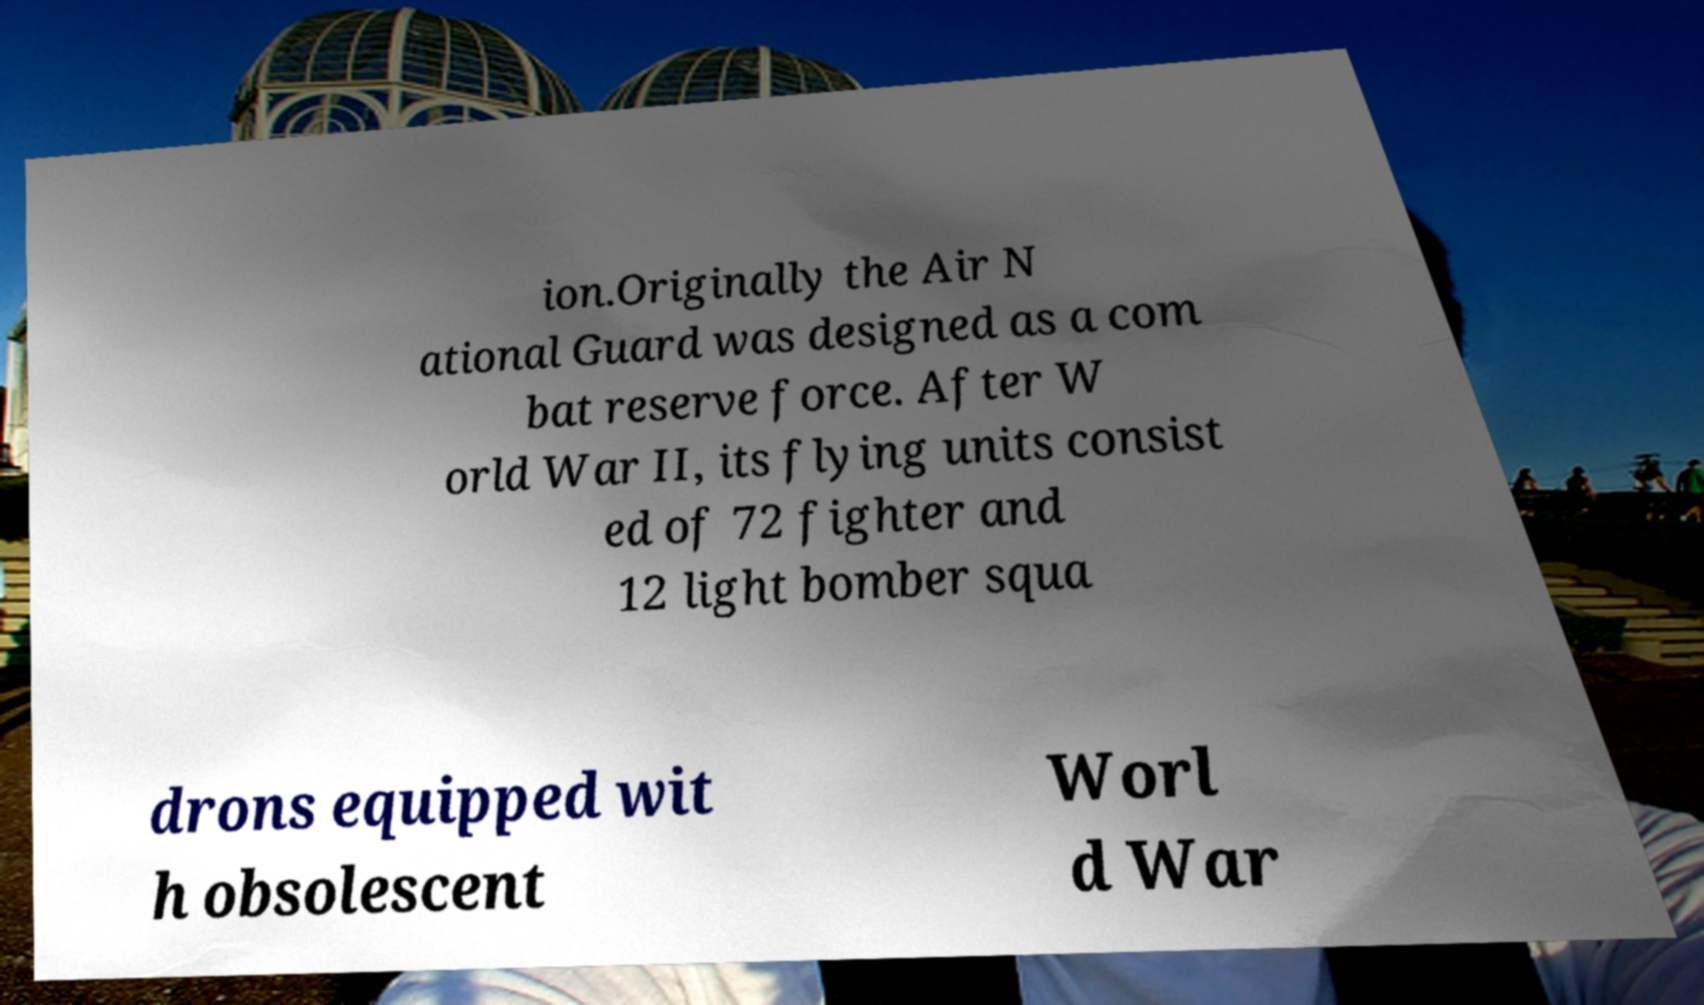What messages or text are displayed in this image? I need them in a readable, typed format. ion.Originally the Air N ational Guard was designed as a com bat reserve force. After W orld War II, its flying units consist ed of 72 fighter and 12 light bomber squa drons equipped wit h obsolescent Worl d War 